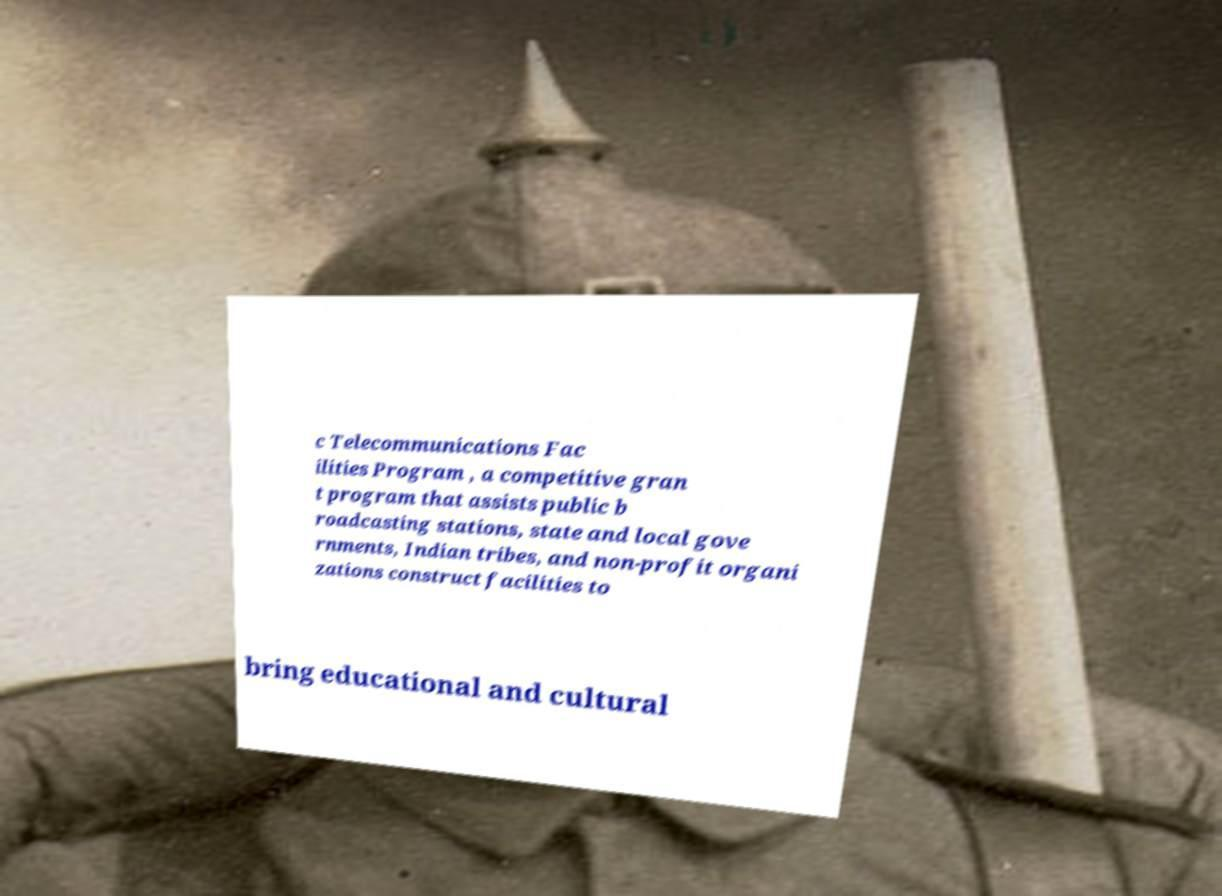Can you accurately transcribe the text from the provided image for me? c Telecommunications Fac ilities Program , a competitive gran t program that assists public b roadcasting stations, state and local gove rnments, Indian tribes, and non-profit organi zations construct facilities to bring educational and cultural 